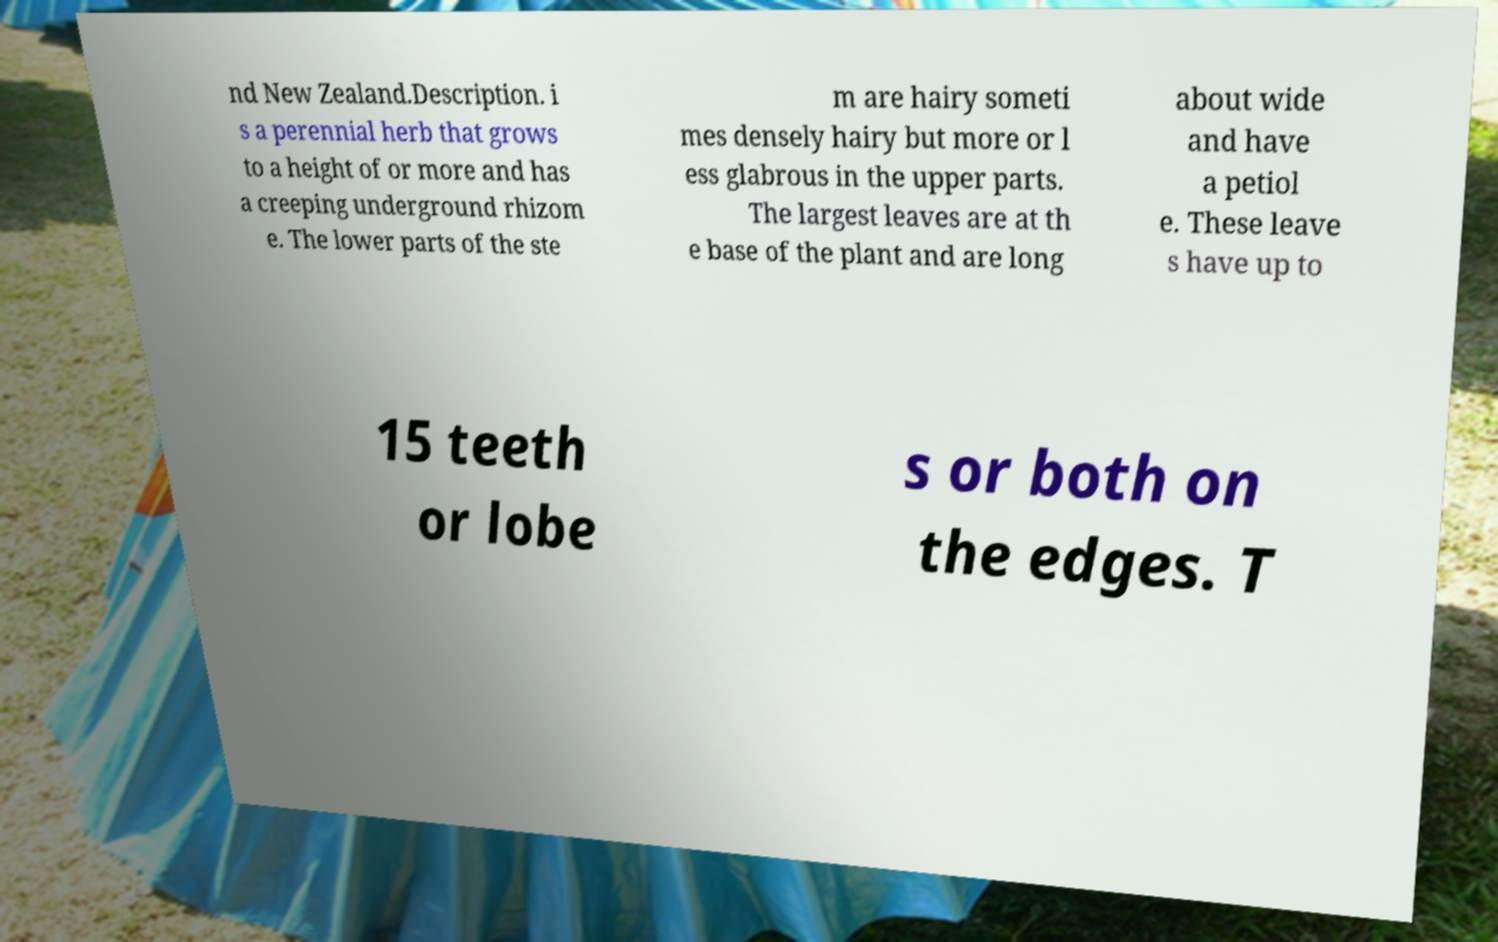I need the written content from this picture converted into text. Can you do that? nd New Zealand.Description. i s a perennial herb that grows to a height of or more and has a creeping underground rhizom e. The lower parts of the ste m are hairy someti mes densely hairy but more or l ess glabrous in the upper parts. The largest leaves are at th e base of the plant and are long about wide and have a petiol e. These leave s have up to 15 teeth or lobe s or both on the edges. T 